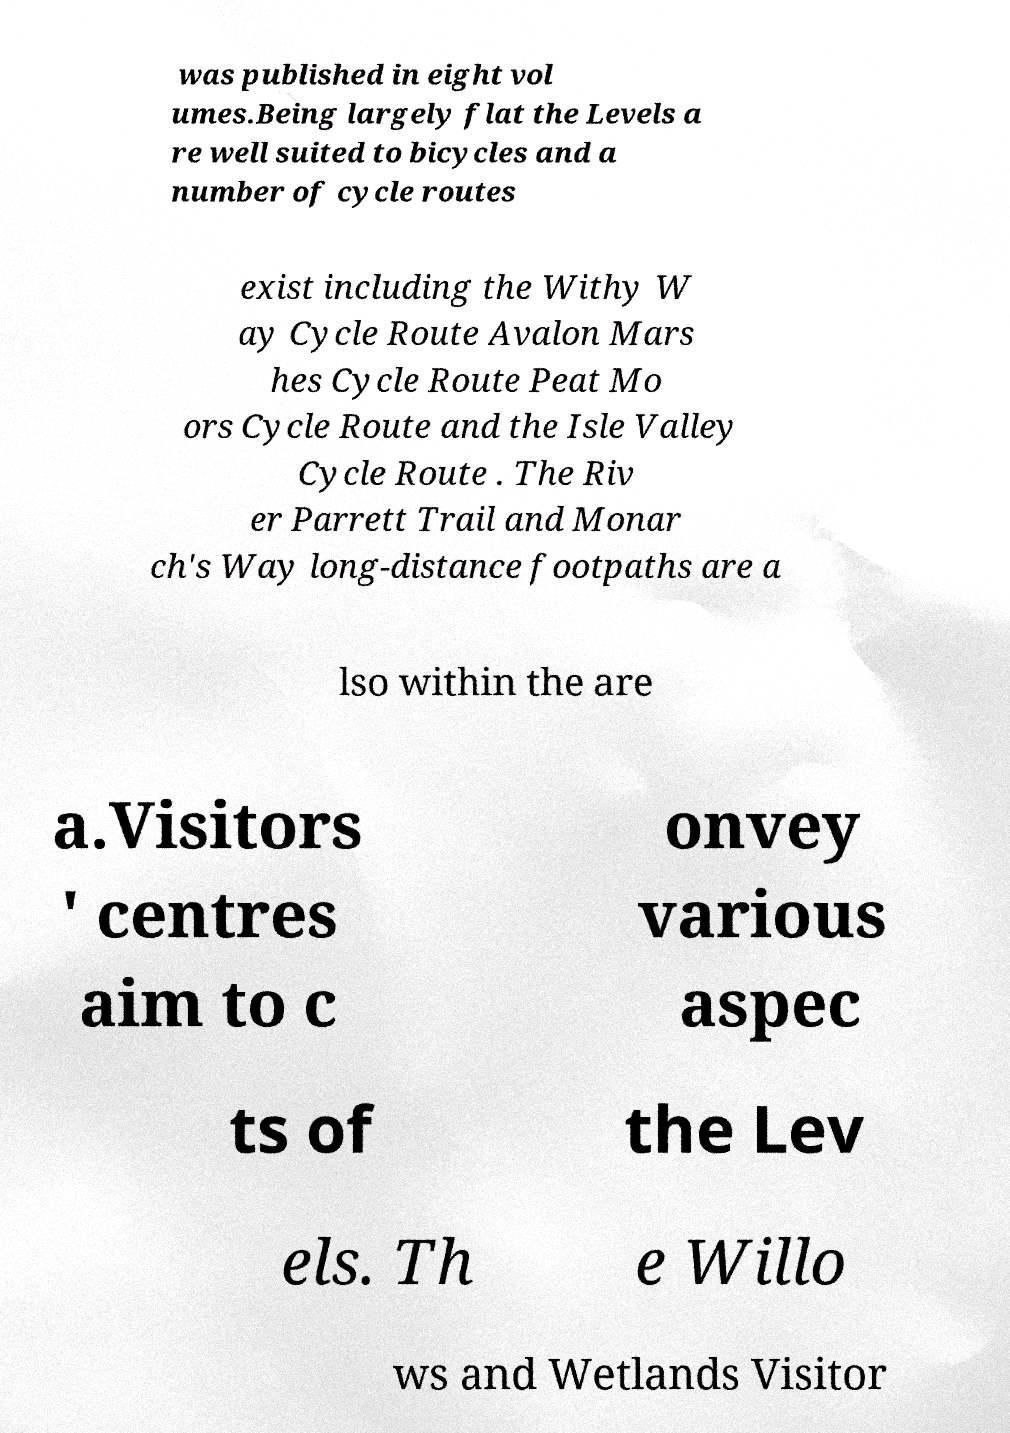Can you read and provide the text displayed in the image?This photo seems to have some interesting text. Can you extract and type it out for me? was published in eight vol umes.Being largely flat the Levels a re well suited to bicycles and a number of cycle routes exist including the Withy W ay Cycle Route Avalon Mars hes Cycle Route Peat Mo ors Cycle Route and the Isle Valley Cycle Route . The Riv er Parrett Trail and Monar ch's Way long-distance footpaths are a lso within the are a.Visitors ' centres aim to c onvey various aspec ts of the Lev els. Th e Willo ws and Wetlands Visitor 